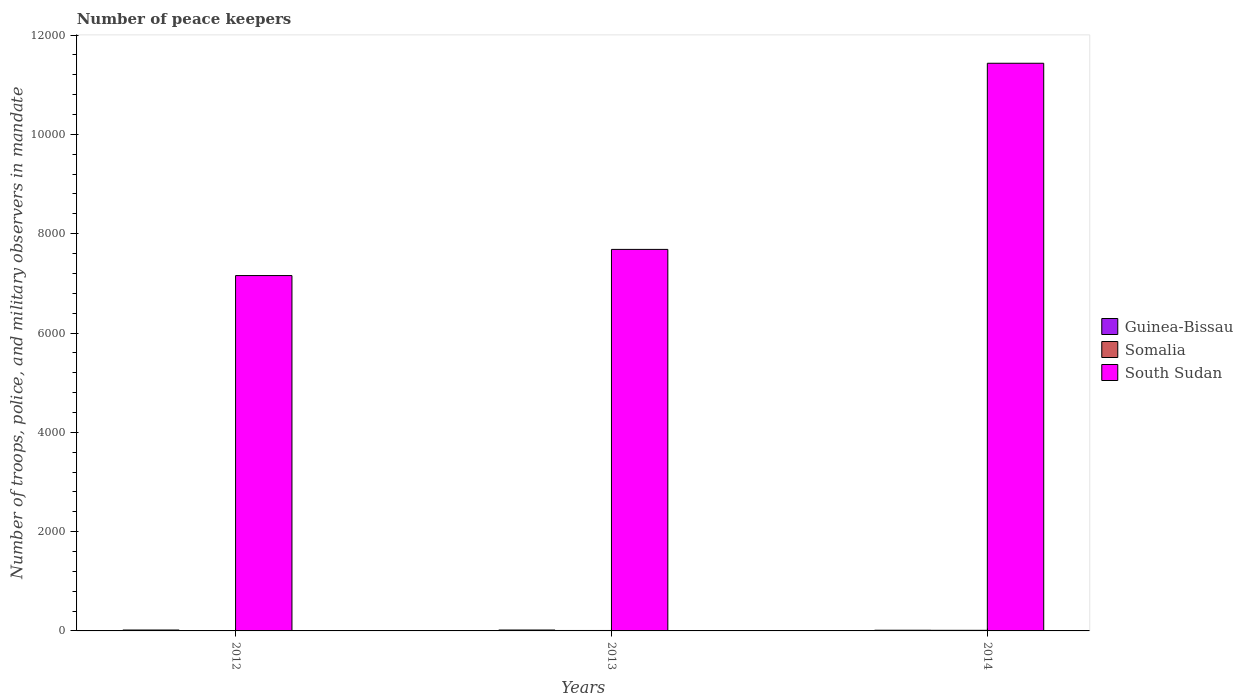How many different coloured bars are there?
Your answer should be very brief. 3. How many groups of bars are there?
Keep it short and to the point. 3. Are the number of bars per tick equal to the number of legend labels?
Offer a very short reply. Yes. Are the number of bars on each tick of the X-axis equal?
Offer a very short reply. Yes. How many bars are there on the 3rd tick from the left?
Your answer should be very brief. 3. How many bars are there on the 3rd tick from the right?
Your answer should be compact. 3. Across all years, what is the maximum number of peace keepers in in South Sudan?
Make the answer very short. 1.14e+04. Across all years, what is the minimum number of peace keepers in in South Sudan?
Provide a short and direct response. 7157. In which year was the number of peace keepers in in Guinea-Bissau maximum?
Make the answer very short. 2012. In which year was the number of peace keepers in in Somalia minimum?
Make the answer very short. 2012. What is the total number of peace keepers in in Guinea-Bissau in the graph?
Give a very brief answer. 50. What is the difference between the number of peace keepers in in South Sudan in 2012 and that in 2014?
Make the answer very short. -4276. What is the difference between the number of peace keepers in in South Sudan in 2014 and the number of peace keepers in in Guinea-Bissau in 2013?
Provide a succinct answer. 1.14e+04. What is the average number of peace keepers in in South Sudan per year?
Ensure brevity in your answer.  8758. In the year 2014, what is the difference between the number of peace keepers in in Guinea-Bissau and number of peace keepers in in South Sudan?
Offer a very short reply. -1.14e+04. What is the ratio of the number of peace keepers in in South Sudan in 2012 to that in 2013?
Offer a terse response. 0.93. Is the number of peace keepers in in Guinea-Bissau in 2013 less than that in 2014?
Make the answer very short. No. What is the difference between the highest and the second highest number of peace keepers in in Guinea-Bissau?
Your response must be concise. 0. What is the difference between the highest and the lowest number of peace keepers in in Somalia?
Keep it short and to the point. 9. In how many years, is the number of peace keepers in in South Sudan greater than the average number of peace keepers in in South Sudan taken over all years?
Provide a short and direct response. 1. Is the sum of the number of peace keepers in in South Sudan in 2012 and 2013 greater than the maximum number of peace keepers in in Somalia across all years?
Offer a terse response. Yes. What does the 3rd bar from the left in 2013 represents?
Provide a short and direct response. South Sudan. What does the 2nd bar from the right in 2014 represents?
Offer a terse response. Somalia. How many bars are there?
Your answer should be very brief. 9. Are all the bars in the graph horizontal?
Provide a short and direct response. No. How many years are there in the graph?
Your answer should be compact. 3. What is the difference between two consecutive major ticks on the Y-axis?
Your answer should be very brief. 2000. Are the values on the major ticks of Y-axis written in scientific E-notation?
Keep it short and to the point. No. Does the graph contain any zero values?
Ensure brevity in your answer.  No. What is the title of the graph?
Your answer should be very brief. Number of peace keepers. Does "Gambia, The" appear as one of the legend labels in the graph?
Offer a very short reply. No. What is the label or title of the X-axis?
Keep it short and to the point. Years. What is the label or title of the Y-axis?
Your answer should be very brief. Number of troops, police, and military observers in mandate. What is the Number of troops, police, and military observers in mandate of Somalia in 2012?
Give a very brief answer. 3. What is the Number of troops, police, and military observers in mandate of South Sudan in 2012?
Make the answer very short. 7157. What is the Number of troops, police, and military observers in mandate of Guinea-Bissau in 2013?
Offer a very short reply. 18. What is the Number of troops, police, and military observers in mandate of South Sudan in 2013?
Ensure brevity in your answer.  7684. What is the Number of troops, police, and military observers in mandate in Somalia in 2014?
Your response must be concise. 12. What is the Number of troops, police, and military observers in mandate of South Sudan in 2014?
Give a very brief answer. 1.14e+04. Across all years, what is the maximum Number of troops, police, and military observers in mandate of Guinea-Bissau?
Offer a very short reply. 18. Across all years, what is the maximum Number of troops, police, and military observers in mandate of South Sudan?
Your response must be concise. 1.14e+04. Across all years, what is the minimum Number of troops, police, and military observers in mandate in Guinea-Bissau?
Your answer should be compact. 14. Across all years, what is the minimum Number of troops, police, and military observers in mandate of Somalia?
Ensure brevity in your answer.  3. Across all years, what is the minimum Number of troops, police, and military observers in mandate of South Sudan?
Provide a short and direct response. 7157. What is the total Number of troops, police, and military observers in mandate of Guinea-Bissau in the graph?
Ensure brevity in your answer.  50. What is the total Number of troops, police, and military observers in mandate in Somalia in the graph?
Keep it short and to the point. 24. What is the total Number of troops, police, and military observers in mandate in South Sudan in the graph?
Keep it short and to the point. 2.63e+04. What is the difference between the Number of troops, police, and military observers in mandate of Somalia in 2012 and that in 2013?
Provide a succinct answer. -6. What is the difference between the Number of troops, police, and military observers in mandate of South Sudan in 2012 and that in 2013?
Provide a short and direct response. -527. What is the difference between the Number of troops, police, and military observers in mandate of South Sudan in 2012 and that in 2014?
Make the answer very short. -4276. What is the difference between the Number of troops, police, and military observers in mandate of Guinea-Bissau in 2013 and that in 2014?
Provide a succinct answer. 4. What is the difference between the Number of troops, police, and military observers in mandate in Somalia in 2013 and that in 2014?
Keep it short and to the point. -3. What is the difference between the Number of troops, police, and military observers in mandate of South Sudan in 2013 and that in 2014?
Ensure brevity in your answer.  -3749. What is the difference between the Number of troops, police, and military observers in mandate of Guinea-Bissau in 2012 and the Number of troops, police, and military observers in mandate of South Sudan in 2013?
Offer a very short reply. -7666. What is the difference between the Number of troops, police, and military observers in mandate in Somalia in 2012 and the Number of troops, police, and military observers in mandate in South Sudan in 2013?
Your answer should be compact. -7681. What is the difference between the Number of troops, police, and military observers in mandate in Guinea-Bissau in 2012 and the Number of troops, police, and military observers in mandate in Somalia in 2014?
Give a very brief answer. 6. What is the difference between the Number of troops, police, and military observers in mandate in Guinea-Bissau in 2012 and the Number of troops, police, and military observers in mandate in South Sudan in 2014?
Provide a succinct answer. -1.14e+04. What is the difference between the Number of troops, police, and military observers in mandate of Somalia in 2012 and the Number of troops, police, and military observers in mandate of South Sudan in 2014?
Your answer should be compact. -1.14e+04. What is the difference between the Number of troops, police, and military observers in mandate of Guinea-Bissau in 2013 and the Number of troops, police, and military observers in mandate of Somalia in 2014?
Ensure brevity in your answer.  6. What is the difference between the Number of troops, police, and military observers in mandate in Guinea-Bissau in 2013 and the Number of troops, police, and military observers in mandate in South Sudan in 2014?
Keep it short and to the point. -1.14e+04. What is the difference between the Number of troops, police, and military observers in mandate of Somalia in 2013 and the Number of troops, police, and military observers in mandate of South Sudan in 2014?
Your answer should be very brief. -1.14e+04. What is the average Number of troops, police, and military observers in mandate in Guinea-Bissau per year?
Keep it short and to the point. 16.67. What is the average Number of troops, police, and military observers in mandate of Somalia per year?
Your answer should be very brief. 8. What is the average Number of troops, police, and military observers in mandate of South Sudan per year?
Your response must be concise. 8758. In the year 2012, what is the difference between the Number of troops, police, and military observers in mandate of Guinea-Bissau and Number of troops, police, and military observers in mandate of South Sudan?
Your answer should be very brief. -7139. In the year 2012, what is the difference between the Number of troops, police, and military observers in mandate of Somalia and Number of troops, police, and military observers in mandate of South Sudan?
Offer a terse response. -7154. In the year 2013, what is the difference between the Number of troops, police, and military observers in mandate of Guinea-Bissau and Number of troops, police, and military observers in mandate of South Sudan?
Offer a very short reply. -7666. In the year 2013, what is the difference between the Number of troops, police, and military observers in mandate of Somalia and Number of troops, police, and military observers in mandate of South Sudan?
Make the answer very short. -7675. In the year 2014, what is the difference between the Number of troops, police, and military observers in mandate of Guinea-Bissau and Number of troops, police, and military observers in mandate of South Sudan?
Offer a very short reply. -1.14e+04. In the year 2014, what is the difference between the Number of troops, police, and military observers in mandate in Somalia and Number of troops, police, and military observers in mandate in South Sudan?
Keep it short and to the point. -1.14e+04. What is the ratio of the Number of troops, police, and military observers in mandate in South Sudan in 2012 to that in 2013?
Your response must be concise. 0.93. What is the ratio of the Number of troops, police, and military observers in mandate in Guinea-Bissau in 2012 to that in 2014?
Your answer should be compact. 1.29. What is the ratio of the Number of troops, police, and military observers in mandate in South Sudan in 2012 to that in 2014?
Your answer should be very brief. 0.63. What is the ratio of the Number of troops, police, and military observers in mandate in Somalia in 2013 to that in 2014?
Provide a succinct answer. 0.75. What is the ratio of the Number of troops, police, and military observers in mandate in South Sudan in 2013 to that in 2014?
Make the answer very short. 0.67. What is the difference between the highest and the second highest Number of troops, police, and military observers in mandate in Guinea-Bissau?
Keep it short and to the point. 0. What is the difference between the highest and the second highest Number of troops, police, and military observers in mandate of Somalia?
Provide a short and direct response. 3. What is the difference between the highest and the second highest Number of troops, police, and military observers in mandate in South Sudan?
Your response must be concise. 3749. What is the difference between the highest and the lowest Number of troops, police, and military observers in mandate in South Sudan?
Your response must be concise. 4276. 